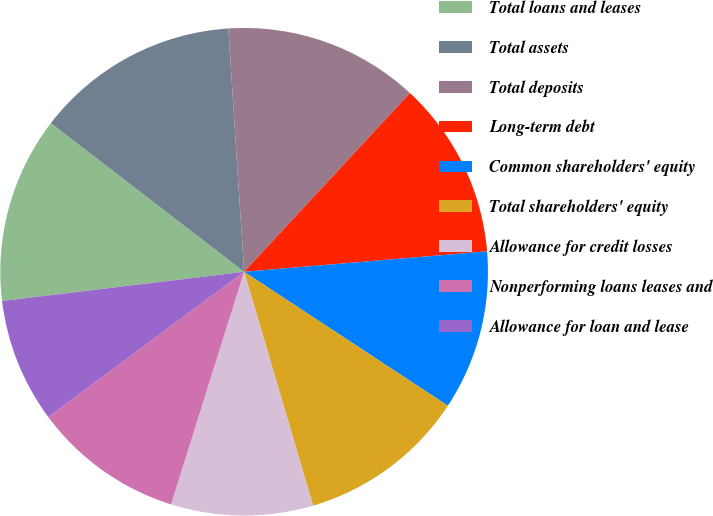Convert chart to OTSL. <chart><loc_0><loc_0><loc_500><loc_500><pie_chart><fcel>Total loans and leases<fcel>Total assets<fcel>Total deposits<fcel>Long-term debt<fcel>Common shareholders' equity<fcel>Total shareholders' equity<fcel>Allowance for credit losses<fcel>Nonperforming loans leases and<fcel>Allowance for loan and lease<nl><fcel>12.35%<fcel>13.53%<fcel>12.94%<fcel>11.76%<fcel>10.59%<fcel>11.18%<fcel>9.41%<fcel>10.0%<fcel>8.24%<nl></chart> 